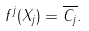Convert formula to latex. <formula><loc_0><loc_0><loc_500><loc_500>f ^ { j } ( X _ { j } ) = \overline { C _ { j } } .</formula> 